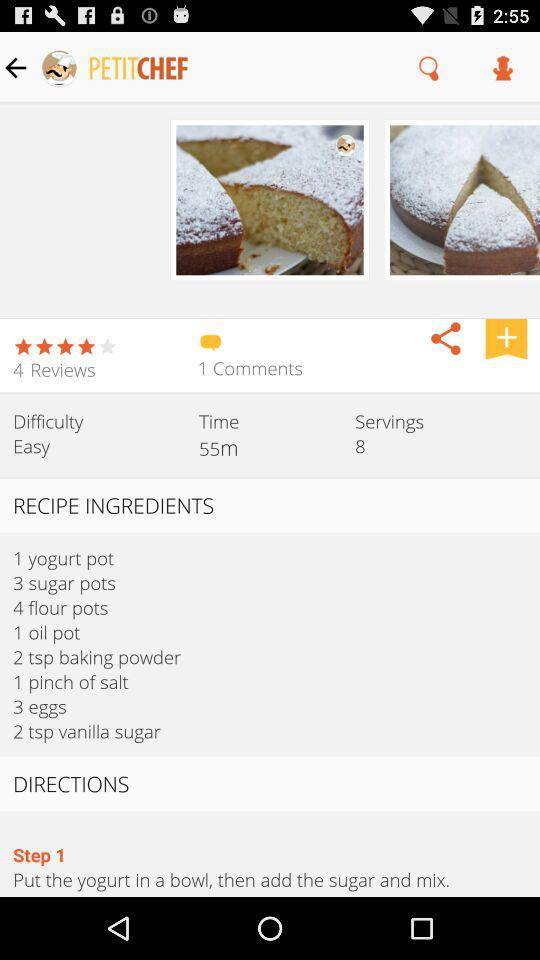What is the star rating? The rating is 4 stars. 